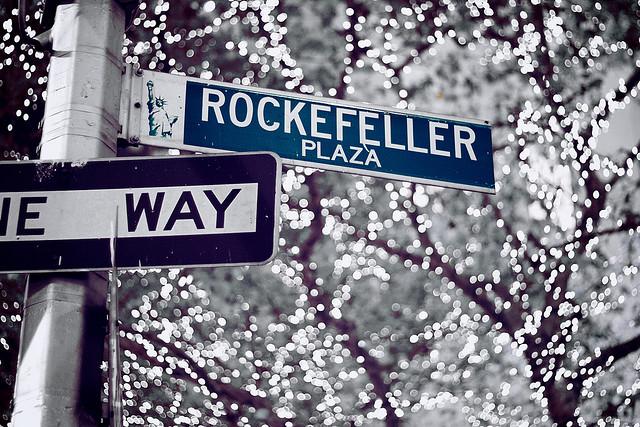What image is on the left of that Green Street sign?
Keep it brief. Statue of liberty. Does this photo have any filter that is being used?
Quick response, please. Yes. What is the name of the plaza?
Write a very short answer. Rockefeller. 